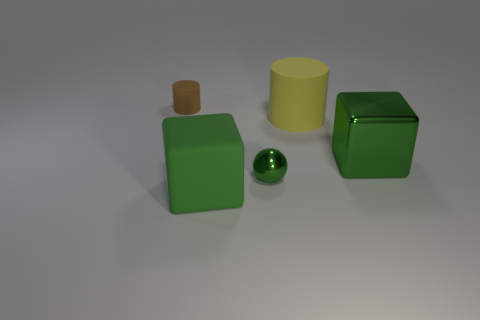Add 2 small yellow spheres. How many objects exist? 7 Subtract all brown cylinders. How many cylinders are left? 1 Subtract all green blocks. How many brown spheres are left? 0 Add 4 small blue rubber balls. How many small blue rubber balls exist? 4 Subtract 0 cyan spheres. How many objects are left? 5 Subtract all spheres. How many objects are left? 4 Subtract 1 blocks. How many blocks are left? 1 Subtract all cyan blocks. Subtract all purple cylinders. How many blocks are left? 2 Subtract all large yellow matte blocks. Subtract all small objects. How many objects are left? 3 Add 1 green matte things. How many green matte things are left? 2 